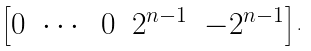Convert formula to latex. <formula><loc_0><loc_0><loc_500><loc_500>\begin{bmatrix} 0 & \cdots & 0 & 2 ^ { n - 1 } & - 2 ^ { n - 1 } \end{bmatrix} .</formula> 